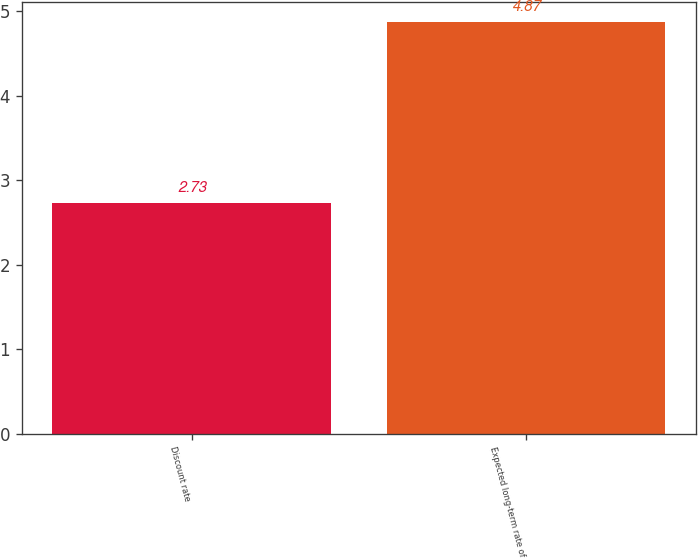<chart> <loc_0><loc_0><loc_500><loc_500><bar_chart><fcel>Discount rate<fcel>Expected long-term rate of<nl><fcel>2.73<fcel>4.87<nl></chart> 